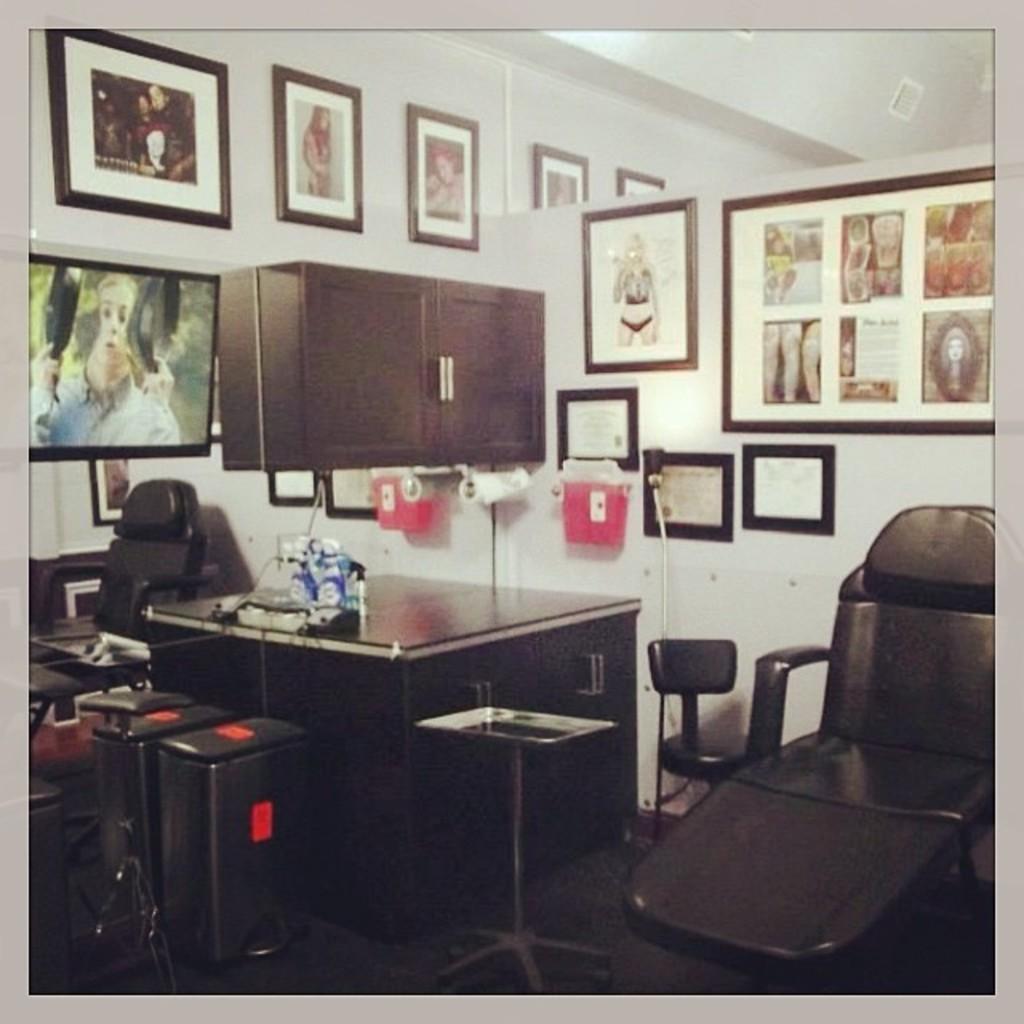In one or two sentences, can you explain what this image depicts? In this image I can see few photo frames attached to the wall. This is a chair. This is a table with some object on it. I think this is a dustbin. I think this is a mirror where we can see the reflection of the chair. I can see another small table. This is a cupboard which is attached to the wall. This is a door handle. 